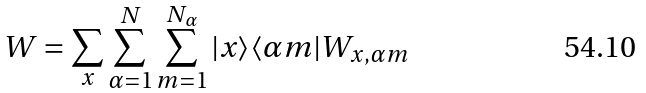<formula> <loc_0><loc_0><loc_500><loc_500>W = \sum _ { x } \sum _ { \alpha = 1 } ^ { N } \sum _ { m = 1 } ^ { N _ { \alpha } } | x \rangle \langle \alpha m | W _ { x , \alpha m }</formula> 